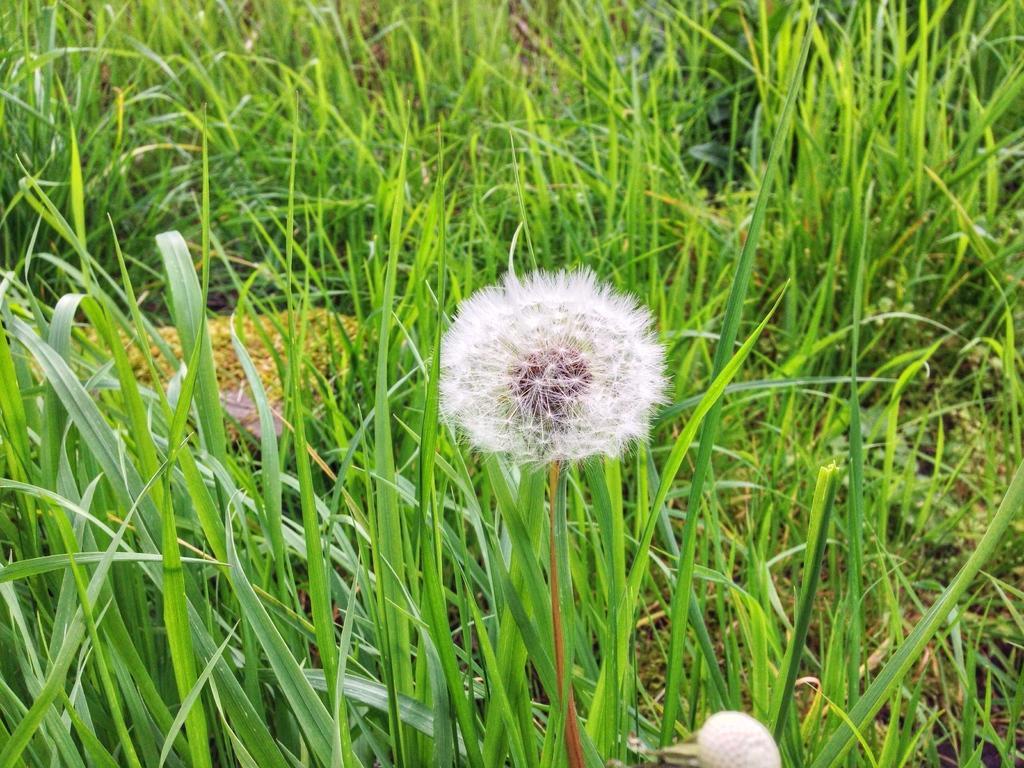How would you summarize this image in a sentence or two? In this image we can see a dandelion, grass and other objects. 